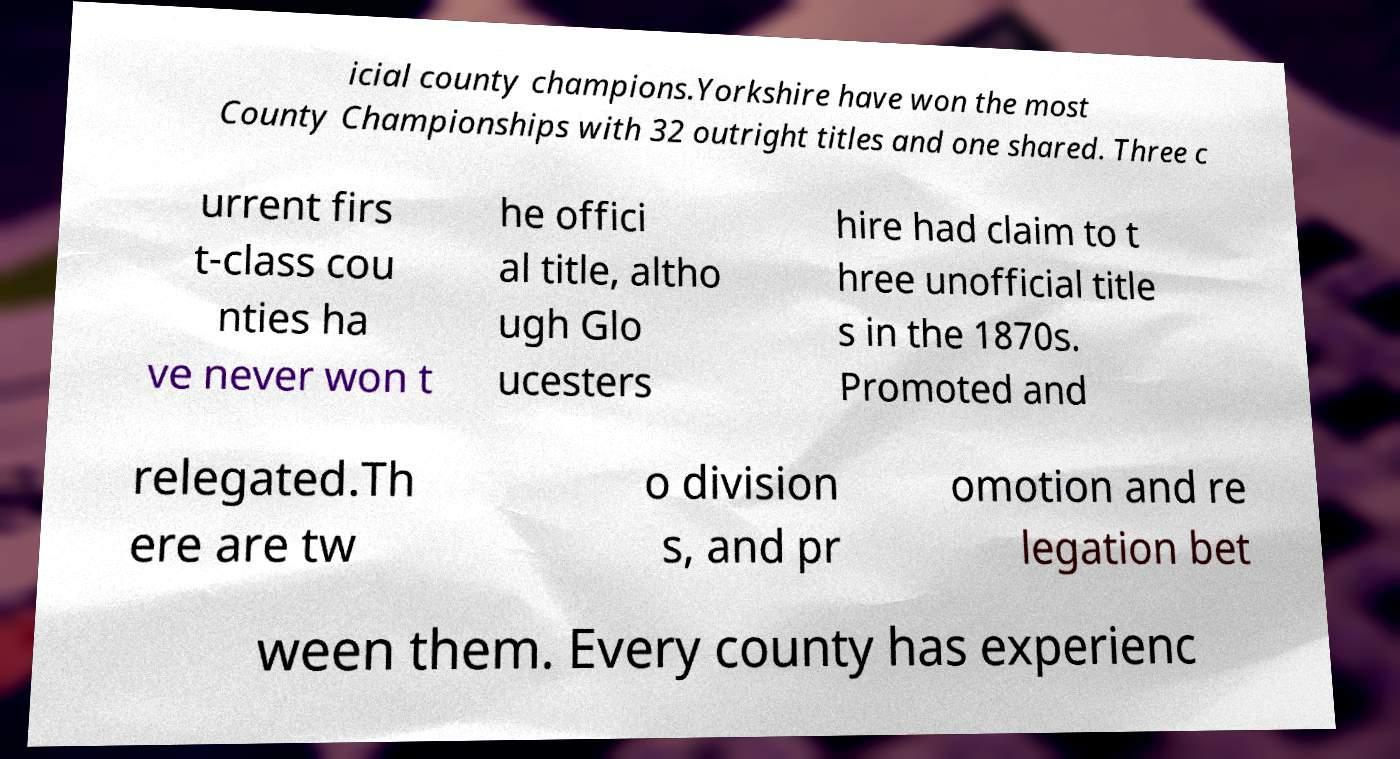Please read and relay the text visible in this image. What does it say? icial county champions.Yorkshire have won the most County Championships with 32 outright titles and one shared. Three c urrent firs t-class cou nties ha ve never won t he offici al title, altho ugh Glo ucesters hire had claim to t hree unofficial title s in the 1870s. Promoted and relegated.Th ere are tw o division s, and pr omotion and re legation bet ween them. Every county has experienc 